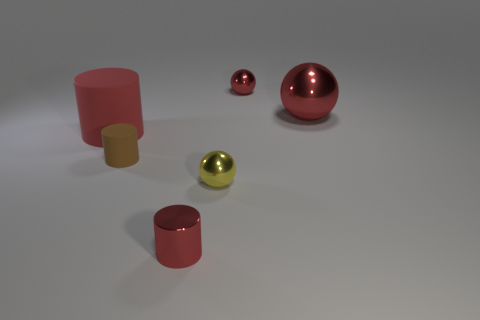How many red things are small cylinders or large cylinders?
Your answer should be very brief. 2. The object that is behind the tiny shiny cylinder and in front of the brown cylinder is what color?
Offer a very short reply. Yellow. How many tiny objects are either red rubber things or matte cubes?
Keep it short and to the point. 0. What size is the other matte object that is the same shape as the small matte thing?
Ensure brevity in your answer.  Large. The yellow object has what shape?
Provide a short and direct response. Sphere. Are the large sphere and the big red object to the left of the large metallic thing made of the same material?
Give a very brief answer. No. How many rubber objects are either tiny red spheres or brown cylinders?
Keep it short and to the point. 1. What is the size of the metal thing to the left of the yellow ball?
Give a very brief answer. Small. What is the size of the other thing that is made of the same material as the tiny brown object?
Offer a very short reply. Large. What number of large matte things have the same color as the large matte cylinder?
Your answer should be very brief. 0. 